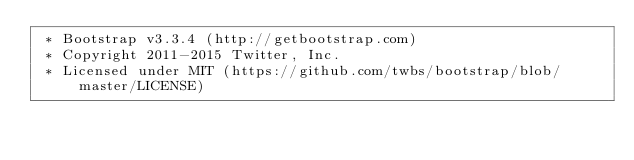<code> <loc_0><loc_0><loc_500><loc_500><_CSS_> * Bootstrap v3.3.4 (http://getbootstrap.com)
 * Copyright 2011-2015 Twitter, Inc.
 * Licensed under MIT (https://github.com/twbs/bootstrap/blob/master/LICENSE)</code> 